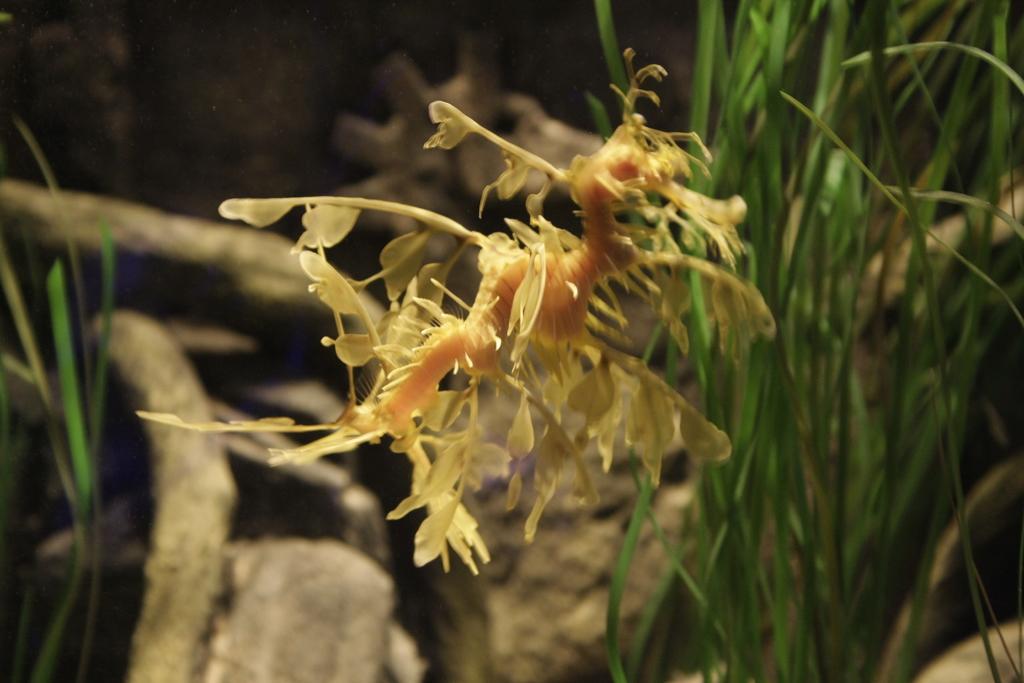Can you describe this image briefly? In this image we can see an insect, there are rocks, and the grass, also the background is blurred. 